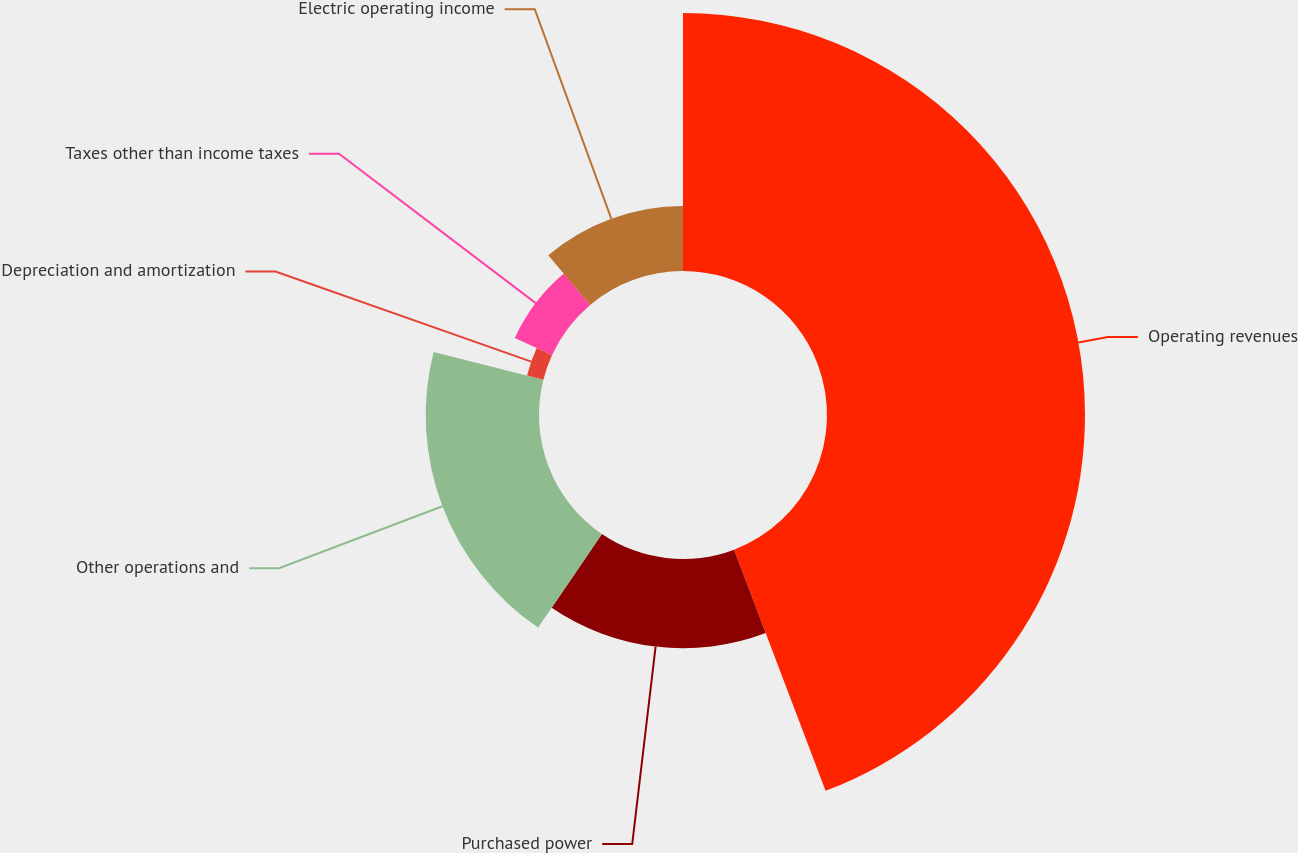<chart> <loc_0><loc_0><loc_500><loc_500><pie_chart><fcel>Operating revenues<fcel>Purchased power<fcel>Other operations and<fcel>Depreciation and amortization<fcel>Taxes other than income taxes<fcel>Electric operating income<nl><fcel>44.23%<fcel>15.29%<fcel>19.42%<fcel>2.89%<fcel>7.02%<fcel>11.15%<nl></chart> 